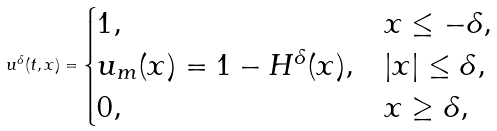Convert formula to latex. <formula><loc_0><loc_0><loc_500><loc_500>u ^ { \delta } ( t , x ) = \begin{cases} 1 , & x \leq - \delta , \\ u _ { m } ( x ) = 1 - H ^ { \delta } ( x ) , & | x | \leq \delta , \\ 0 , & x \geq \delta , \end{cases}</formula> 